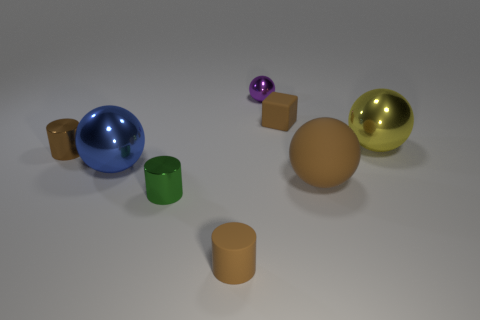Add 2 small gray rubber spheres. How many objects exist? 10 Subtract all cylinders. How many objects are left? 5 Subtract all blue objects. Subtract all brown matte cylinders. How many objects are left? 6 Add 1 brown rubber spheres. How many brown rubber spheres are left? 2 Add 6 big green things. How many big green things exist? 6 Subtract 1 brown cylinders. How many objects are left? 7 